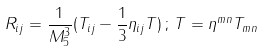<formula> <loc_0><loc_0><loc_500><loc_500>R _ { i j } = \frac { 1 } { M _ { 5 } ^ { 3 } } ( T _ { i j } - \frac { 1 } { 3 } \eta _ { i j } T ) \, ; \, T = \eta ^ { m n } T _ { m n }</formula> 